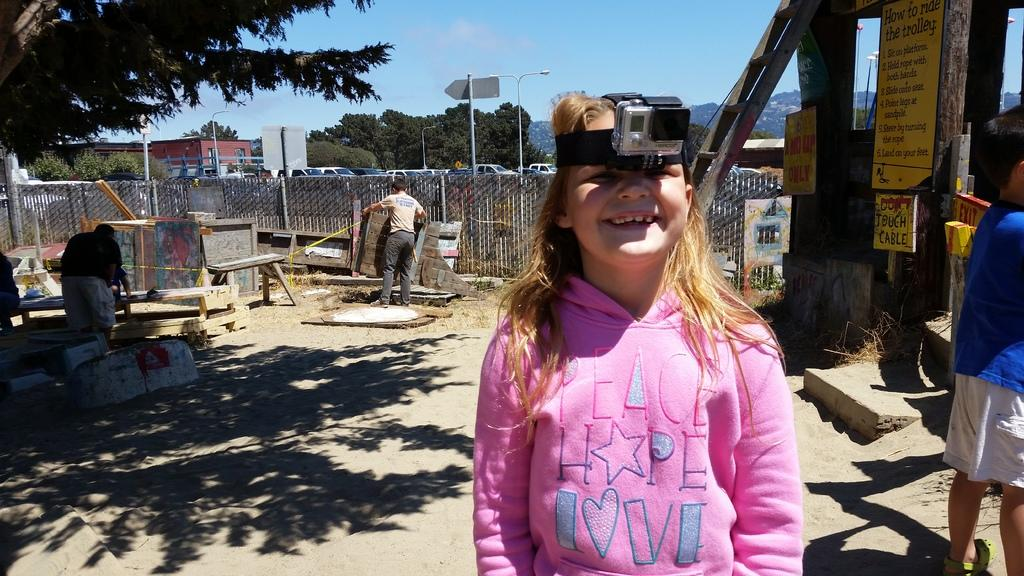What can be seen on the ground in the image? There are people on the ground in the image. What type of signage is present in the image? There are posters in the image. What is used for climbing or reaching higher in the image? There is a ladder in the image. What is used to separate or enclose areas in the image? There is a fence in the image. What type of transportation is visible in the image? There are vehicles in the image. What are the tall, vertical structures in the image? There are poles in the image. What type of small, enclosed structures are present in the image? There are sheds in the image. What type of natural vegetation is visible in the image? There are trees in the image. What additional objects can be seen in the image? There are some objects in the image. What can be seen in the background of the image? The sky is visible in the background of the image. What is the weight of the feeling experienced by the people in the image? There is no information about the weight of any feelings experienced by the people in the image. How does the throat of the person holding the poster in the image look? There is no information about the appearance of anyone's throat in the image. 